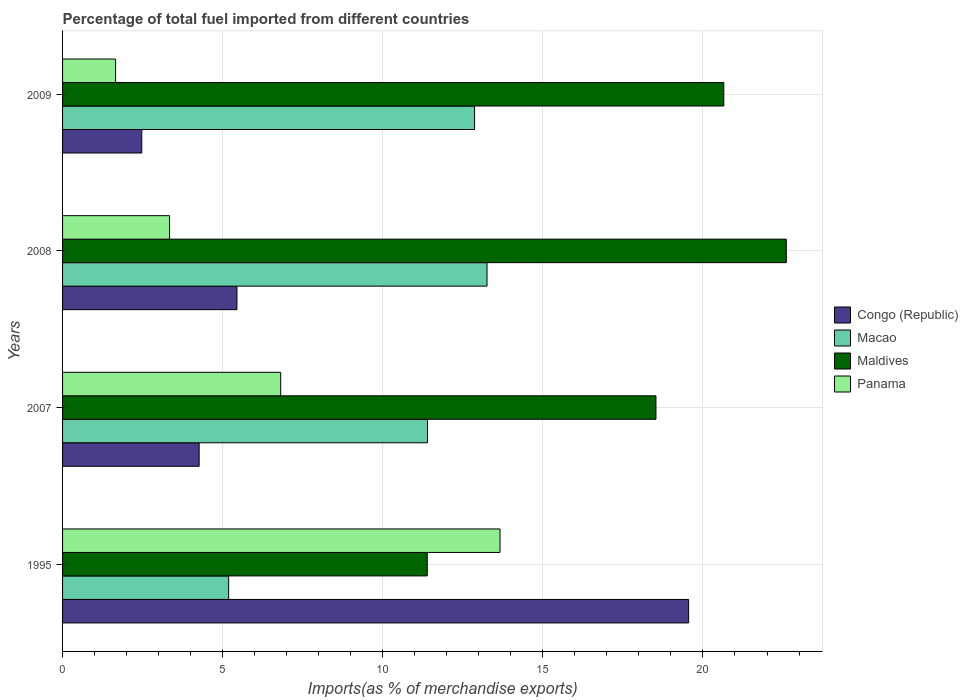How many groups of bars are there?
Your answer should be compact. 4. In how many cases, is the number of bars for a given year not equal to the number of legend labels?
Ensure brevity in your answer.  0. What is the percentage of imports to different countries in Macao in 1995?
Offer a terse response. 5.19. Across all years, what is the maximum percentage of imports to different countries in Panama?
Your response must be concise. 13.66. Across all years, what is the minimum percentage of imports to different countries in Panama?
Give a very brief answer. 1.66. In which year was the percentage of imports to different countries in Congo (Republic) maximum?
Ensure brevity in your answer.  1995. In which year was the percentage of imports to different countries in Maldives minimum?
Offer a terse response. 1995. What is the total percentage of imports to different countries in Panama in the graph?
Your response must be concise. 25.47. What is the difference between the percentage of imports to different countries in Macao in 2007 and that in 2009?
Your answer should be compact. -1.47. What is the difference between the percentage of imports to different countries in Maldives in 2008 and the percentage of imports to different countries in Congo (Republic) in 1995?
Provide a succinct answer. 3.05. What is the average percentage of imports to different countries in Congo (Republic) per year?
Give a very brief answer. 7.93. In the year 1995, what is the difference between the percentage of imports to different countries in Panama and percentage of imports to different countries in Macao?
Give a very brief answer. 8.48. In how many years, is the percentage of imports to different countries in Panama greater than 18 %?
Your answer should be very brief. 0. What is the ratio of the percentage of imports to different countries in Macao in 2007 to that in 2009?
Your answer should be very brief. 0.89. Is the percentage of imports to different countries in Macao in 1995 less than that in 2007?
Offer a very short reply. Yes. Is the difference between the percentage of imports to different countries in Panama in 1995 and 2009 greater than the difference between the percentage of imports to different countries in Macao in 1995 and 2009?
Offer a terse response. Yes. What is the difference between the highest and the second highest percentage of imports to different countries in Maldives?
Your response must be concise. 1.95. What is the difference between the highest and the lowest percentage of imports to different countries in Panama?
Your answer should be compact. 12.01. In how many years, is the percentage of imports to different countries in Congo (Republic) greater than the average percentage of imports to different countries in Congo (Republic) taken over all years?
Ensure brevity in your answer.  1. Is the sum of the percentage of imports to different countries in Macao in 2007 and 2008 greater than the maximum percentage of imports to different countries in Maldives across all years?
Offer a very short reply. Yes. Is it the case that in every year, the sum of the percentage of imports to different countries in Panama and percentage of imports to different countries in Maldives is greater than the sum of percentage of imports to different countries in Macao and percentage of imports to different countries in Congo (Republic)?
Offer a terse response. Yes. What does the 4th bar from the top in 1995 represents?
Make the answer very short. Congo (Republic). What does the 3rd bar from the bottom in 1995 represents?
Offer a very short reply. Maldives. How many bars are there?
Your answer should be very brief. 16. Does the graph contain any zero values?
Ensure brevity in your answer.  No. How are the legend labels stacked?
Give a very brief answer. Vertical. What is the title of the graph?
Offer a very short reply. Percentage of total fuel imported from different countries. What is the label or title of the X-axis?
Offer a terse response. Imports(as % of merchandise exports). What is the Imports(as % of merchandise exports) in Congo (Republic) in 1995?
Give a very brief answer. 19.55. What is the Imports(as % of merchandise exports) in Macao in 1995?
Offer a terse response. 5.19. What is the Imports(as % of merchandise exports) of Maldives in 1995?
Your answer should be very brief. 11.39. What is the Imports(as % of merchandise exports) in Panama in 1995?
Your answer should be very brief. 13.66. What is the Imports(as % of merchandise exports) of Congo (Republic) in 2007?
Provide a short and direct response. 4.27. What is the Imports(as % of merchandise exports) of Macao in 2007?
Give a very brief answer. 11.4. What is the Imports(as % of merchandise exports) of Maldives in 2007?
Provide a short and direct response. 18.53. What is the Imports(as % of merchandise exports) of Panama in 2007?
Offer a terse response. 6.81. What is the Imports(as % of merchandise exports) of Congo (Republic) in 2008?
Keep it short and to the point. 5.45. What is the Imports(as % of merchandise exports) of Macao in 2008?
Provide a succinct answer. 13.26. What is the Imports(as % of merchandise exports) in Maldives in 2008?
Offer a terse response. 22.6. What is the Imports(as % of merchandise exports) of Panama in 2008?
Make the answer very short. 3.34. What is the Imports(as % of merchandise exports) in Congo (Republic) in 2009?
Give a very brief answer. 2.47. What is the Imports(as % of merchandise exports) in Macao in 2009?
Ensure brevity in your answer.  12.87. What is the Imports(as % of merchandise exports) in Maldives in 2009?
Offer a very short reply. 20.65. What is the Imports(as % of merchandise exports) in Panama in 2009?
Give a very brief answer. 1.66. Across all years, what is the maximum Imports(as % of merchandise exports) of Congo (Republic)?
Keep it short and to the point. 19.55. Across all years, what is the maximum Imports(as % of merchandise exports) of Macao?
Provide a succinct answer. 13.26. Across all years, what is the maximum Imports(as % of merchandise exports) of Maldives?
Provide a succinct answer. 22.6. Across all years, what is the maximum Imports(as % of merchandise exports) in Panama?
Offer a very short reply. 13.66. Across all years, what is the minimum Imports(as % of merchandise exports) of Congo (Republic)?
Make the answer very short. 2.47. Across all years, what is the minimum Imports(as % of merchandise exports) of Macao?
Provide a short and direct response. 5.19. Across all years, what is the minimum Imports(as % of merchandise exports) in Maldives?
Your response must be concise. 11.39. Across all years, what is the minimum Imports(as % of merchandise exports) in Panama?
Offer a very short reply. 1.66. What is the total Imports(as % of merchandise exports) of Congo (Republic) in the graph?
Give a very brief answer. 31.74. What is the total Imports(as % of merchandise exports) in Macao in the graph?
Your response must be concise. 42.71. What is the total Imports(as % of merchandise exports) of Maldives in the graph?
Provide a short and direct response. 73.17. What is the total Imports(as % of merchandise exports) of Panama in the graph?
Give a very brief answer. 25.47. What is the difference between the Imports(as % of merchandise exports) of Congo (Republic) in 1995 and that in 2007?
Ensure brevity in your answer.  15.29. What is the difference between the Imports(as % of merchandise exports) in Macao in 1995 and that in 2007?
Your answer should be compact. -6.21. What is the difference between the Imports(as % of merchandise exports) in Maldives in 1995 and that in 2007?
Keep it short and to the point. -7.14. What is the difference between the Imports(as % of merchandise exports) of Panama in 1995 and that in 2007?
Your response must be concise. 6.85. What is the difference between the Imports(as % of merchandise exports) of Congo (Republic) in 1995 and that in 2008?
Offer a very short reply. 14.11. What is the difference between the Imports(as % of merchandise exports) in Macao in 1995 and that in 2008?
Your answer should be compact. -8.07. What is the difference between the Imports(as % of merchandise exports) in Maldives in 1995 and that in 2008?
Make the answer very short. -11.21. What is the difference between the Imports(as % of merchandise exports) in Panama in 1995 and that in 2008?
Provide a short and direct response. 10.32. What is the difference between the Imports(as % of merchandise exports) in Congo (Republic) in 1995 and that in 2009?
Provide a short and direct response. 17.08. What is the difference between the Imports(as % of merchandise exports) of Macao in 1995 and that in 2009?
Provide a short and direct response. -7.68. What is the difference between the Imports(as % of merchandise exports) in Maldives in 1995 and that in 2009?
Give a very brief answer. -9.26. What is the difference between the Imports(as % of merchandise exports) in Panama in 1995 and that in 2009?
Keep it short and to the point. 12.01. What is the difference between the Imports(as % of merchandise exports) in Congo (Republic) in 2007 and that in 2008?
Make the answer very short. -1.18. What is the difference between the Imports(as % of merchandise exports) in Macao in 2007 and that in 2008?
Make the answer very short. -1.86. What is the difference between the Imports(as % of merchandise exports) in Maldives in 2007 and that in 2008?
Give a very brief answer. -4.07. What is the difference between the Imports(as % of merchandise exports) in Panama in 2007 and that in 2008?
Offer a very short reply. 3.47. What is the difference between the Imports(as % of merchandise exports) in Congo (Republic) in 2007 and that in 2009?
Offer a very short reply. 1.79. What is the difference between the Imports(as % of merchandise exports) of Macao in 2007 and that in 2009?
Your answer should be very brief. -1.47. What is the difference between the Imports(as % of merchandise exports) in Maldives in 2007 and that in 2009?
Give a very brief answer. -2.12. What is the difference between the Imports(as % of merchandise exports) of Panama in 2007 and that in 2009?
Offer a terse response. 5.16. What is the difference between the Imports(as % of merchandise exports) in Congo (Republic) in 2008 and that in 2009?
Make the answer very short. 2.97. What is the difference between the Imports(as % of merchandise exports) in Macao in 2008 and that in 2009?
Keep it short and to the point. 0.39. What is the difference between the Imports(as % of merchandise exports) in Maldives in 2008 and that in 2009?
Your answer should be very brief. 1.95. What is the difference between the Imports(as % of merchandise exports) in Panama in 2008 and that in 2009?
Ensure brevity in your answer.  1.69. What is the difference between the Imports(as % of merchandise exports) of Congo (Republic) in 1995 and the Imports(as % of merchandise exports) of Macao in 2007?
Your response must be concise. 8.15. What is the difference between the Imports(as % of merchandise exports) of Congo (Republic) in 1995 and the Imports(as % of merchandise exports) of Maldives in 2007?
Your answer should be very brief. 1.02. What is the difference between the Imports(as % of merchandise exports) in Congo (Republic) in 1995 and the Imports(as % of merchandise exports) in Panama in 2007?
Provide a succinct answer. 12.74. What is the difference between the Imports(as % of merchandise exports) of Macao in 1995 and the Imports(as % of merchandise exports) of Maldives in 2007?
Provide a short and direct response. -13.35. What is the difference between the Imports(as % of merchandise exports) of Macao in 1995 and the Imports(as % of merchandise exports) of Panama in 2007?
Keep it short and to the point. -1.63. What is the difference between the Imports(as % of merchandise exports) of Maldives in 1995 and the Imports(as % of merchandise exports) of Panama in 2007?
Provide a short and direct response. 4.58. What is the difference between the Imports(as % of merchandise exports) in Congo (Republic) in 1995 and the Imports(as % of merchandise exports) in Macao in 2008?
Your answer should be very brief. 6.3. What is the difference between the Imports(as % of merchandise exports) in Congo (Republic) in 1995 and the Imports(as % of merchandise exports) in Maldives in 2008?
Make the answer very short. -3.05. What is the difference between the Imports(as % of merchandise exports) of Congo (Republic) in 1995 and the Imports(as % of merchandise exports) of Panama in 2008?
Ensure brevity in your answer.  16.21. What is the difference between the Imports(as % of merchandise exports) in Macao in 1995 and the Imports(as % of merchandise exports) in Maldives in 2008?
Ensure brevity in your answer.  -17.42. What is the difference between the Imports(as % of merchandise exports) of Macao in 1995 and the Imports(as % of merchandise exports) of Panama in 2008?
Provide a succinct answer. 1.85. What is the difference between the Imports(as % of merchandise exports) in Maldives in 1995 and the Imports(as % of merchandise exports) in Panama in 2008?
Your answer should be very brief. 8.05. What is the difference between the Imports(as % of merchandise exports) in Congo (Republic) in 1995 and the Imports(as % of merchandise exports) in Macao in 2009?
Your answer should be compact. 6.69. What is the difference between the Imports(as % of merchandise exports) in Congo (Republic) in 1995 and the Imports(as % of merchandise exports) in Maldives in 2009?
Ensure brevity in your answer.  -1.1. What is the difference between the Imports(as % of merchandise exports) in Congo (Republic) in 1995 and the Imports(as % of merchandise exports) in Panama in 2009?
Give a very brief answer. 17.9. What is the difference between the Imports(as % of merchandise exports) of Macao in 1995 and the Imports(as % of merchandise exports) of Maldives in 2009?
Your answer should be very brief. -15.46. What is the difference between the Imports(as % of merchandise exports) in Macao in 1995 and the Imports(as % of merchandise exports) in Panama in 2009?
Your answer should be very brief. 3.53. What is the difference between the Imports(as % of merchandise exports) in Maldives in 1995 and the Imports(as % of merchandise exports) in Panama in 2009?
Offer a terse response. 9.73. What is the difference between the Imports(as % of merchandise exports) of Congo (Republic) in 2007 and the Imports(as % of merchandise exports) of Macao in 2008?
Give a very brief answer. -8.99. What is the difference between the Imports(as % of merchandise exports) in Congo (Republic) in 2007 and the Imports(as % of merchandise exports) in Maldives in 2008?
Make the answer very short. -18.34. What is the difference between the Imports(as % of merchandise exports) in Congo (Republic) in 2007 and the Imports(as % of merchandise exports) in Panama in 2008?
Make the answer very short. 0.92. What is the difference between the Imports(as % of merchandise exports) in Macao in 2007 and the Imports(as % of merchandise exports) in Maldives in 2008?
Offer a very short reply. -11.2. What is the difference between the Imports(as % of merchandise exports) of Macao in 2007 and the Imports(as % of merchandise exports) of Panama in 2008?
Make the answer very short. 8.06. What is the difference between the Imports(as % of merchandise exports) of Maldives in 2007 and the Imports(as % of merchandise exports) of Panama in 2008?
Ensure brevity in your answer.  15.19. What is the difference between the Imports(as % of merchandise exports) in Congo (Republic) in 2007 and the Imports(as % of merchandise exports) in Macao in 2009?
Give a very brief answer. -8.6. What is the difference between the Imports(as % of merchandise exports) in Congo (Republic) in 2007 and the Imports(as % of merchandise exports) in Maldives in 2009?
Your answer should be very brief. -16.38. What is the difference between the Imports(as % of merchandise exports) of Congo (Republic) in 2007 and the Imports(as % of merchandise exports) of Panama in 2009?
Your response must be concise. 2.61. What is the difference between the Imports(as % of merchandise exports) in Macao in 2007 and the Imports(as % of merchandise exports) in Maldives in 2009?
Offer a very short reply. -9.25. What is the difference between the Imports(as % of merchandise exports) in Macao in 2007 and the Imports(as % of merchandise exports) in Panama in 2009?
Provide a succinct answer. 9.74. What is the difference between the Imports(as % of merchandise exports) in Maldives in 2007 and the Imports(as % of merchandise exports) in Panama in 2009?
Provide a succinct answer. 16.88. What is the difference between the Imports(as % of merchandise exports) of Congo (Republic) in 2008 and the Imports(as % of merchandise exports) of Macao in 2009?
Give a very brief answer. -7.42. What is the difference between the Imports(as % of merchandise exports) of Congo (Republic) in 2008 and the Imports(as % of merchandise exports) of Maldives in 2009?
Your response must be concise. -15.2. What is the difference between the Imports(as % of merchandise exports) of Congo (Republic) in 2008 and the Imports(as % of merchandise exports) of Panama in 2009?
Give a very brief answer. 3.79. What is the difference between the Imports(as % of merchandise exports) in Macao in 2008 and the Imports(as % of merchandise exports) in Maldives in 2009?
Provide a succinct answer. -7.39. What is the difference between the Imports(as % of merchandise exports) of Macao in 2008 and the Imports(as % of merchandise exports) of Panama in 2009?
Your answer should be compact. 11.6. What is the difference between the Imports(as % of merchandise exports) of Maldives in 2008 and the Imports(as % of merchandise exports) of Panama in 2009?
Provide a succinct answer. 20.95. What is the average Imports(as % of merchandise exports) of Congo (Republic) per year?
Keep it short and to the point. 7.93. What is the average Imports(as % of merchandise exports) in Macao per year?
Your answer should be very brief. 10.68. What is the average Imports(as % of merchandise exports) in Maldives per year?
Ensure brevity in your answer.  18.29. What is the average Imports(as % of merchandise exports) in Panama per year?
Offer a very short reply. 6.37. In the year 1995, what is the difference between the Imports(as % of merchandise exports) of Congo (Republic) and Imports(as % of merchandise exports) of Macao?
Offer a very short reply. 14.37. In the year 1995, what is the difference between the Imports(as % of merchandise exports) of Congo (Republic) and Imports(as % of merchandise exports) of Maldives?
Provide a short and direct response. 8.16. In the year 1995, what is the difference between the Imports(as % of merchandise exports) in Congo (Republic) and Imports(as % of merchandise exports) in Panama?
Offer a terse response. 5.89. In the year 1995, what is the difference between the Imports(as % of merchandise exports) of Macao and Imports(as % of merchandise exports) of Maldives?
Ensure brevity in your answer.  -6.2. In the year 1995, what is the difference between the Imports(as % of merchandise exports) of Macao and Imports(as % of merchandise exports) of Panama?
Your answer should be compact. -8.48. In the year 1995, what is the difference between the Imports(as % of merchandise exports) of Maldives and Imports(as % of merchandise exports) of Panama?
Provide a succinct answer. -2.27. In the year 2007, what is the difference between the Imports(as % of merchandise exports) of Congo (Republic) and Imports(as % of merchandise exports) of Macao?
Ensure brevity in your answer.  -7.13. In the year 2007, what is the difference between the Imports(as % of merchandise exports) of Congo (Republic) and Imports(as % of merchandise exports) of Maldives?
Offer a terse response. -14.27. In the year 2007, what is the difference between the Imports(as % of merchandise exports) in Congo (Republic) and Imports(as % of merchandise exports) in Panama?
Provide a short and direct response. -2.55. In the year 2007, what is the difference between the Imports(as % of merchandise exports) of Macao and Imports(as % of merchandise exports) of Maldives?
Offer a very short reply. -7.13. In the year 2007, what is the difference between the Imports(as % of merchandise exports) in Macao and Imports(as % of merchandise exports) in Panama?
Offer a very short reply. 4.59. In the year 2007, what is the difference between the Imports(as % of merchandise exports) of Maldives and Imports(as % of merchandise exports) of Panama?
Offer a terse response. 11.72. In the year 2008, what is the difference between the Imports(as % of merchandise exports) of Congo (Republic) and Imports(as % of merchandise exports) of Macao?
Ensure brevity in your answer.  -7.81. In the year 2008, what is the difference between the Imports(as % of merchandise exports) of Congo (Republic) and Imports(as % of merchandise exports) of Maldives?
Your answer should be very brief. -17.16. In the year 2008, what is the difference between the Imports(as % of merchandise exports) of Congo (Republic) and Imports(as % of merchandise exports) of Panama?
Ensure brevity in your answer.  2.1. In the year 2008, what is the difference between the Imports(as % of merchandise exports) in Macao and Imports(as % of merchandise exports) in Maldives?
Ensure brevity in your answer.  -9.35. In the year 2008, what is the difference between the Imports(as % of merchandise exports) in Macao and Imports(as % of merchandise exports) in Panama?
Make the answer very short. 9.91. In the year 2008, what is the difference between the Imports(as % of merchandise exports) of Maldives and Imports(as % of merchandise exports) of Panama?
Provide a short and direct response. 19.26. In the year 2009, what is the difference between the Imports(as % of merchandise exports) in Congo (Republic) and Imports(as % of merchandise exports) in Macao?
Make the answer very short. -10.39. In the year 2009, what is the difference between the Imports(as % of merchandise exports) in Congo (Republic) and Imports(as % of merchandise exports) in Maldives?
Provide a succinct answer. -18.18. In the year 2009, what is the difference between the Imports(as % of merchandise exports) of Congo (Republic) and Imports(as % of merchandise exports) of Panama?
Your answer should be very brief. 0.82. In the year 2009, what is the difference between the Imports(as % of merchandise exports) in Macao and Imports(as % of merchandise exports) in Maldives?
Offer a terse response. -7.78. In the year 2009, what is the difference between the Imports(as % of merchandise exports) in Macao and Imports(as % of merchandise exports) in Panama?
Make the answer very short. 11.21. In the year 2009, what is the difference between the Imports(as % of merchandise exports) in Maldives and Imports(as % of merchandise exports) in Panama?
Offer a terse response. 18.99. What is the ratio of the Imports(as % of merchandise exports) of Congo (Republic) in 1995 to that in 2007?
Make the answer very short. 4.58. What is the ratio of the Imports(as % of merchandise exports) in Macao in 1995 to that in 2007?
Offer a very short reply. 0.46. What is the ratio of the Imports(as % of merchandise exports) in Maldives in 1995 to that in 2007?
Ensure brevity in your answer.  0.61. What is the ratio of the Imports(as % of merchandise exports) of Panama in 1995 to that in 2007?
Ensure brevity in your answer.  2.01. What is the ratio of the Imports(as % of merchandise exports) in Congo (Republic) in 1995 to that in 2008?
Ensure brevity in your answer.  3.59. What is the ratio of the Imports(as % of merchandise exports) of Macao in 1995 to that in 2008?
Give a very brief answer. 0.39. What is the ratio of the Imports(as % of merchandise exports) of Maldives in 1995 to that in 2008?
Ensure brevity in your answer.  0.5. What is the ratio of the Imports(as % of merchandise exports) in Panama in 1995 to that in 2008?
Provide a short and direct response. 4.09. What is the ratio of the Imports(as % of merchandise exports) in Congo (Republic) in 1995 to that in 2009?
Your answer should be very brief. 7.91. What is the ratio of the Imports(as % of merchandise exports) in Macao in 1995 to that in 2009?
Your answer should be very brief. 0.4. What is the ratio of the Imports(as % of merchandise exports) in Maldives in 1995 to that in 2009?
Give a very brief answer. 0.55. What is the ratio of the Imports(as % of merchandise exports) in Panama in 1995 to that in 2009?
Ensure brevity in your answer.  8.25. What is the ratio of the Imports(as % of merchandise exports) of Congo (Republic) in 2007 to that in 2008?
Give a very brief answer. 0.78. What is the ratio of the Imports(as % of merchandise exports) in Macao in 2007 to that in 2008?
Provide a succinct answer. 0.86. What is the ratio of the Imports(as % of merchandise exports) of Maldives in 2007 to that in 2008?
Your answer should be very brief. 0.82. What is the ratio of the Imports(as % of merchandise exports) of Panama in 2007 to that in 2008?
Make the answer very short. 2.04. What is the ratio of the Imports(as % of merchandise exports) in Congo (Republic) in 2007 to that in 2009?
Provide a short and direct response. 1.72. What is the ratio of the Imports(as % of merchandise exports) of Macao in 2007 to that in 2009?
Ensure brevity in your answer.  0.89. What is the ratio of the Imports(as % of merchandise exports) of Maldives in 2007 to that in 2009?
Your response must be concise. 0.9. What is the ratio of the Imports(as % of merchandise exports) of Panama in 2007 to that in 2009?
Give a very brief answer. 4.11. What is the ratio of the Imports(as % of merchandise exports) of Congo (Republic) in 2008 to that in 2009?
Provide a short and direct response. 2.2. What is the ratio of the Imports(as % of merchandise exports) in Macao in 2008 to that in 2009?
Your response must be concise. 1.03. What is the ratio of the Imports(as % of merchandise exports) of Maldives in 2008 to that in 2009?
Your answer should be very brief. 1.09. What is the ratio of the Imports(as % of merchandise exports) of Panama in 2008 to that in 2009?
Your answer should be compact. 2.02. What is the difference between the highest and the second highest Imports(as % of merchandise exports) in Congo (Republic)?
Provide a short and direct response. 14.11. What is the difference between the highest and the second highest Imports(as % of merchandise exports) in Macao?
Offer a very short reply. 0.39. What is the difference between the highest and the second highest Imports(as % of merchandise exports) of Maldives?
Offer a terse response. 1.95. What is the difference between the highest and the second highest Imports(as % of merchandise exports) of Panama?
Your answer should be very brief. 6.85. What is the difference between the highest and the lowest Imports(as % of merchandise exports) in Congo (Republic)?
Provide a succinct answer. 17.08. What is the difference between the highest and the lowest Imports(as % of merchandise exports) of Macao?
Your answer should be compact. 8.07. What is the difference between the highest and the lowest Imports(as % of merchandise exports) in Maldives?
Ensure brevity in your answer.  11.21. What is the difference between the highest and the lowest Imports(as % of merchandise exports) in Panama?
Make the answer very short. 12.01. 